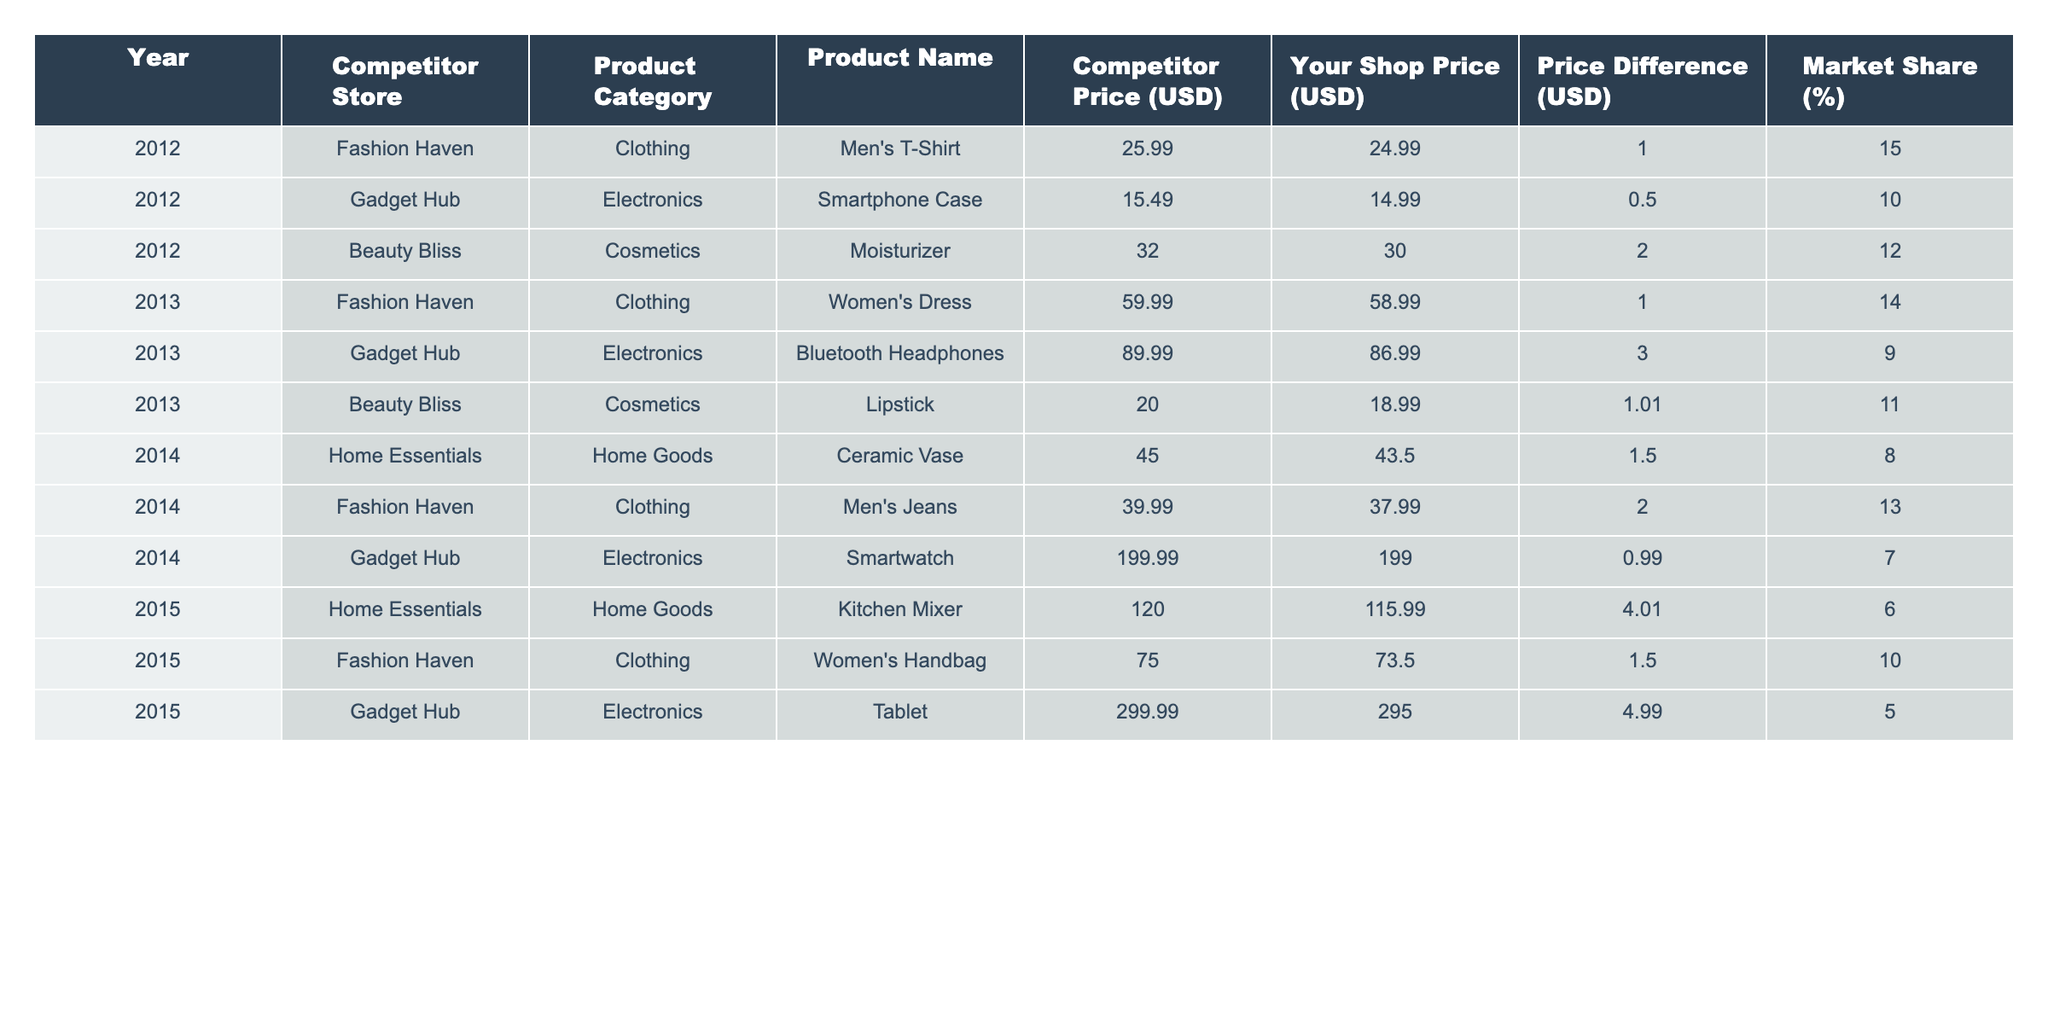What was the price difference for the "Smartphone Case" in 2012? Referring to the table, the competitor price for the "Smartphone Case" was $15.49, and your shop price was $14.99, leading to a price difference of $0.50.
Answer: $0.50 Which product had the highest price in 2015? Looking at the table, the "Tablet" from Gadget Hub was priced at $299.99, which is higher than all other products listed for 2015.
Answer: Tablet What is the average price difference for all products across the years listed? Calculating the price differences: $1.00 (Men's T-Shirt) + $0.50 (Smartphone Case) + $2.00 (Moisturizer) + $1.00 (Women's Dress) + $3.00 (Bluetooth Headphones) + $1.01 (Lipstick) + $1.50 (Ceramic Vase) + $2.00 (Men's Jeans) + $0.99 (Smartwatch) + $4.01 (Kitchen Mixer) + $1.50 (Women's Handbag) + $4.99 (Tablet) gives a total of $19.50. Dividing this by 12 products gives an average price difference of approximately $1.625.
Answer: $1.63 Did the competitor "Gadget Hub" offer cheaper prices than your shop in all years? Checking the table, in 2012, "Gadget Hub" had a price of $15.49 compared to your price of $14.99; in 2013, $89.99 compared to $86.99; in 2014, $199.99 compared to $199.00; and in 2015, $299.99 compared to $295.00. In all cases, your prices were lower.
Answer: Yes Which year had the highest market share for "Beauty Bliss"? The market share for "Beauty Bliss" in the recorded years is 12% in 2012, 11% in 2013, and there are no entries for 2014 or 2015. Therefore, 2012 had the highest market share.
Answer: 2012 How much lower was your shop's price than the competitor's for the "Women's Dress" in 2013? The competitor's price for the "Women's Dress" was $59.99, while your price was $58.99, resulting in a price difference of $1.00.
Answer: $1.00 Which product category had the lowest market share in 2014? Looking at the table, "Home Goods" with a market share of 8% had the lowest percentage compared to Clothing (13%) and Electronics (7%) in the same year.
Answer: Home Goods Calculate the total number of years each competitor was present in the table. The table includes data for three competitors: "Fashion Haven," "Gadget Hub," and "Beauty Bliss." "Fashion Haven" had products in all four years, "Gadget Hub" had products in three years, and "Beauty Bliss" had products in two years, totaling to 4 + 3 + 2 = 9 years across all competitors.
Answer: 9 years 